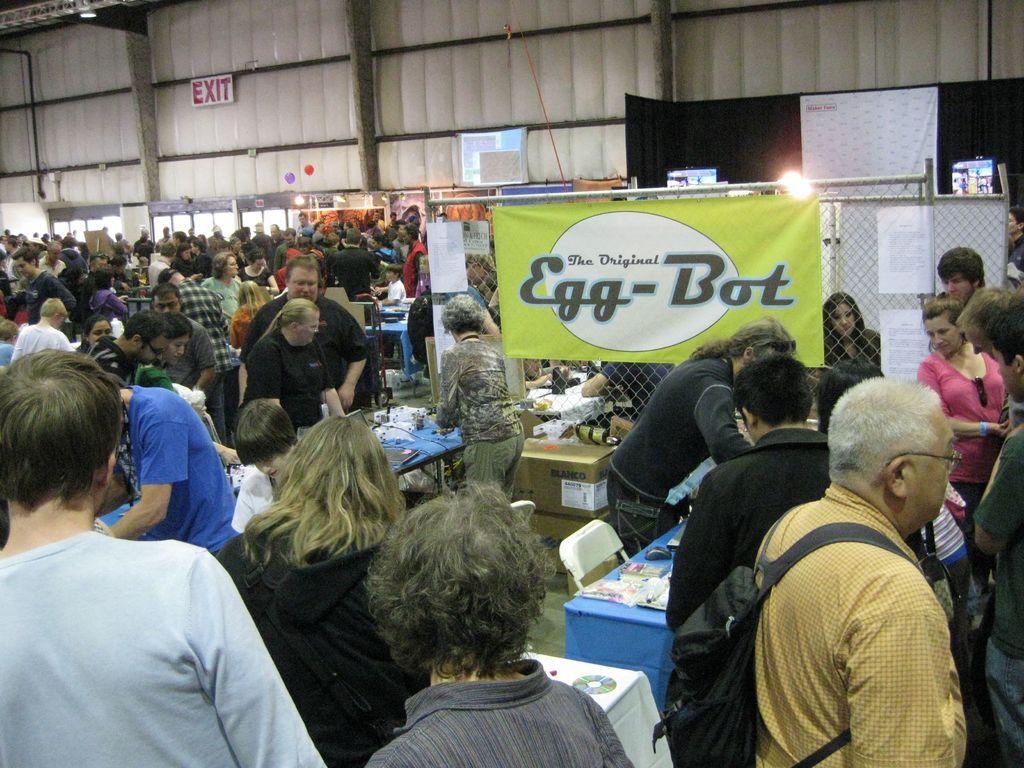In one or two sentences, can you explain what this image depicts? In this image we can see a group of people standing beside the tables. We can also see a banner to a fence. On the backside we can see a wall. 